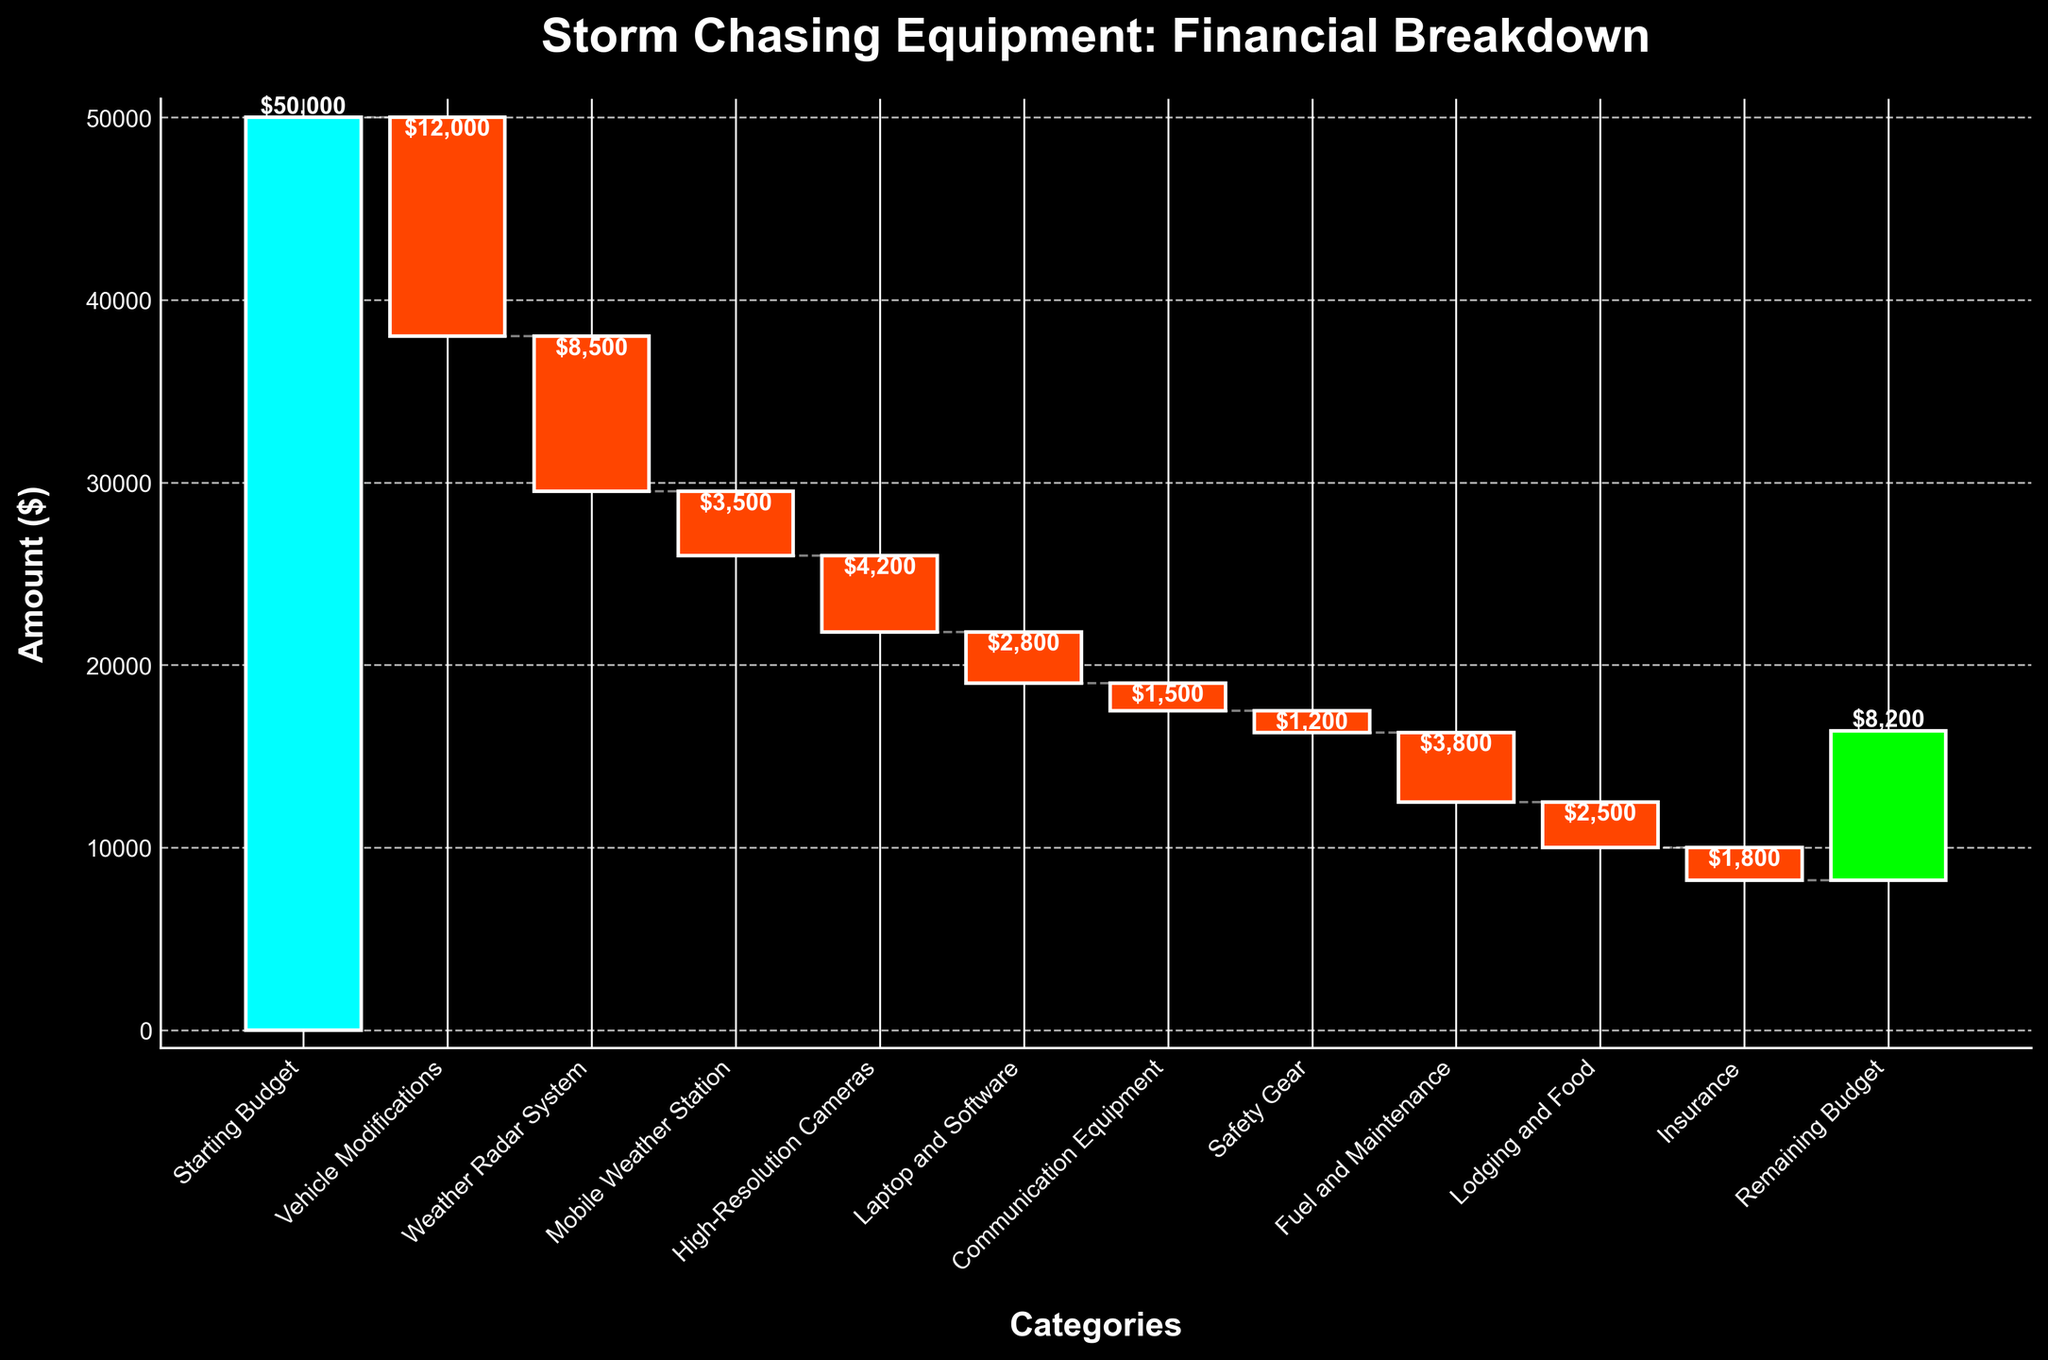What is the title of the chart? The title of the chart is usually found at the top of it, summarizing its content. In this case, it is labelled as 'Storm Chasing Equipment: Financial Breakdown'.
Answer: Storm Chasing Equipment: Financial Breakdown How much was the starting budget for storm chasing? This figure represents the initial amount allocated for spending. According to the chart, the starting budget is shown as $50,000.
Answer: $50,000 Which category had the highest expenditure? By looking at the length of the bars and the numerical labels beside them, the longest negative bar represents the highest expenditure. The 'Vehicle Modifications' category shows a value of -$12,000.
Answer: Vehicle Modifications What is the total expenditure on vehicle modifications and weather radar system? To find the total, add the value for 'Vehicle Modifications' and 'Weather Radar System' together: -$12,000 + -$8,500 = -$20,500.
Answer: $20,500 Which category was the last contributing factor to decrease the budget before the remaining budget? The sequence of categories from left to right shows the spending breakdown. The 'Insurance' category appears right before 'Remaining Budget'.
Answer: Insurance How much is the remaining budget after all expenditures? The final value at the end of the waterfall chart, which signifies the remaining amount after all expenditures, is $8,200.
Answer: $8,200 How does the expenditure on high-resolution cameras compare to the expenditure on laptop and software? Comparing the lengths and values of the bars of 'High-Resolution Cameras' (-$4,200) and 'Laptop and Software' (-$2,800), we see that high-resolution cameras cost $1,400 more than laptop and software.
Answer: $1,400 What were the total expenditures on 'Communication Equipment', 'Safety Gear', and 'Fuel and Maintenance'? Adding the values for 'Communication Equipment' (-$1,500), 'Safety Gear' (-$1,200), and 'Fuel and Maintenance' (-$3,800) gives: -$1,500 + -$1,200 + -$3,800 = -$6,500.
Answer: $6,500 What was the overall impact of 'Lodging and Food' on the budget? The 'Lodging and Food' category shows an expenditure of -$2,500. Therefore, it decreased the budget by $2,500.
Answer: $2,500 Is the starting budget higher than the remaining budget? By how much? To determine this, we compare the starting budget ($50,000) and the remaining budget ($8,200). Subtract the remaining budget from the starting budget: $50,000 - $8,200 = $41,800.
Answer: $41,800 